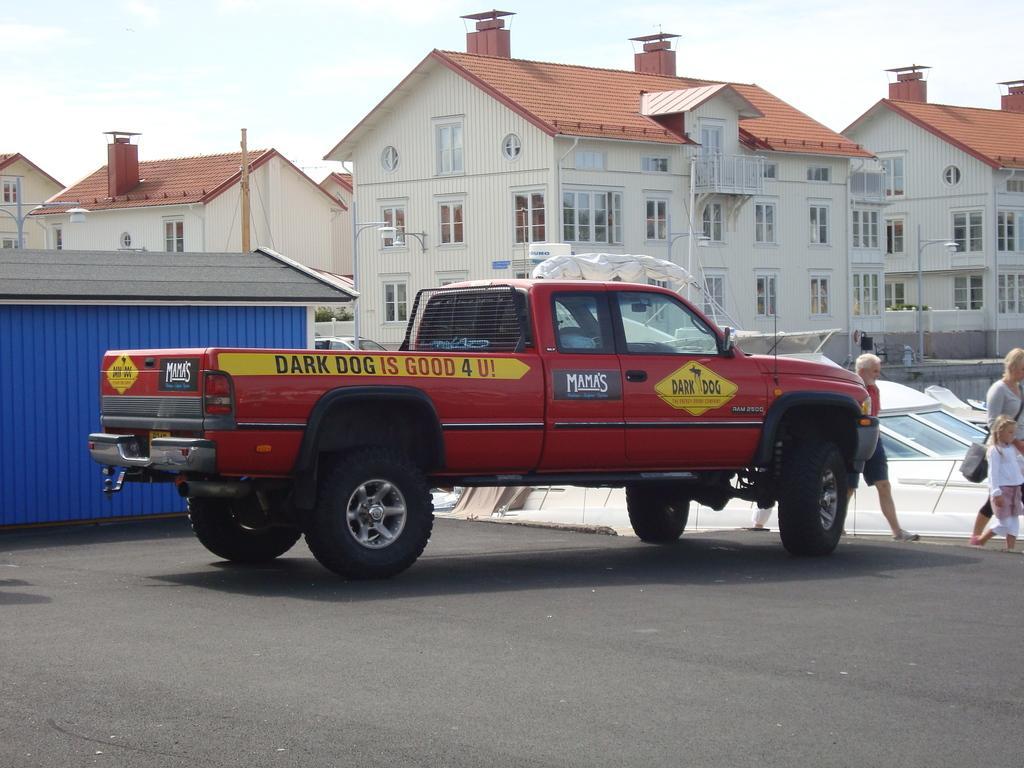Please provide a concise description of this image. At the bottom of the image there is a vehicle on the road. Behind the vehicle there is a shed. On the right side of the image there are three persons walking. Behind them there is a ship with glass windows. In the background there are buildings with roofs, windows, walls and chimneys. And also there are poles with street lights. 